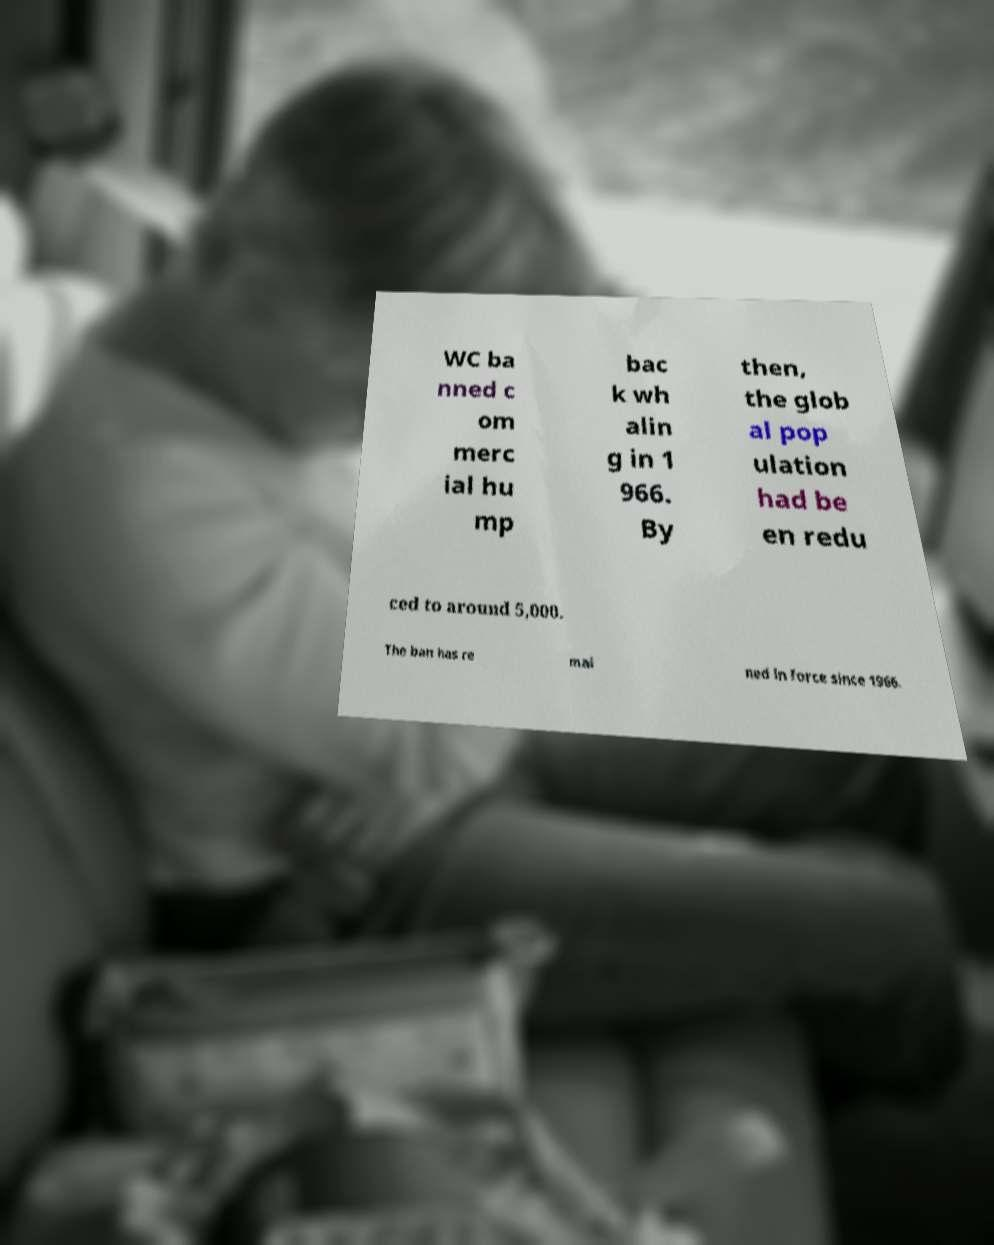Please read and relay the text visible in this image. What does it say? WC ba nned c om merc ial hu mp bac k wh alin g in 1 966. By then, the glob al pop ulation had be en redu ced to around 5,000. The ban has re mai ned in force since 1966. 